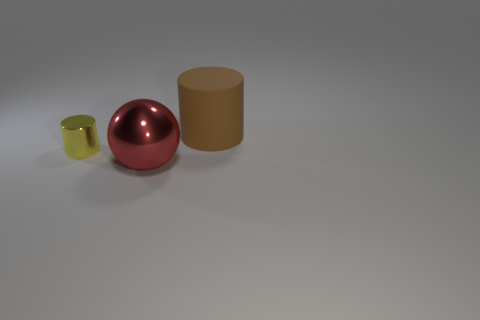The other thing that is the same shape as the rubber thing is what size?
Your answer should be compact. Small. How many things are cylinders to the right of the big red object or large objects behind the yellow metal object?
Provide a succinct answer. 1. The brown matte object that is the same size as the red object is what shape?
Keep it short and to the point. Cylinder. Are there any other small things of the same shape as the red shiny thing?
Provide a succinct answer. No. Is the number of rubber things less than the number of purple spheres?
Your response must be concise. No. There is a metallic object behind the big red shiny thing; is it the same size as the cylinder right of the yellow metal cylinder?
Make the answer very short. No. How many things are large red spheres or purple matte cubes?
Offer a very short reply. 1. There is a metallic object that is in front of the yellow thing; what is its size?
Keep it short and to the point. Large. What number of large brown rubber objects are right of the cylinder that is right of the object left of the red thing?
Ensure brevity in your answer.  0. Is the small shiny thing the same color as the metal sphere?
Your answer should be very brief. No. 